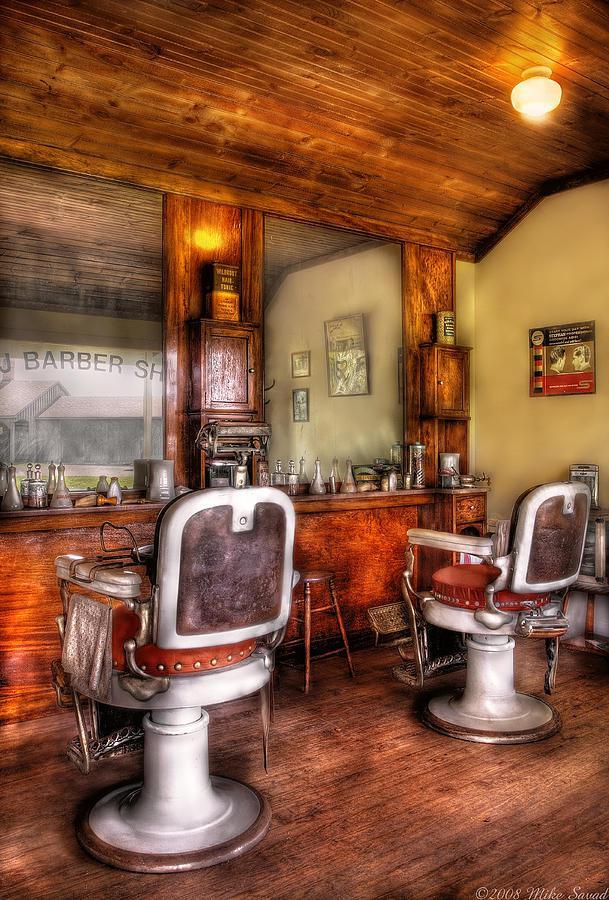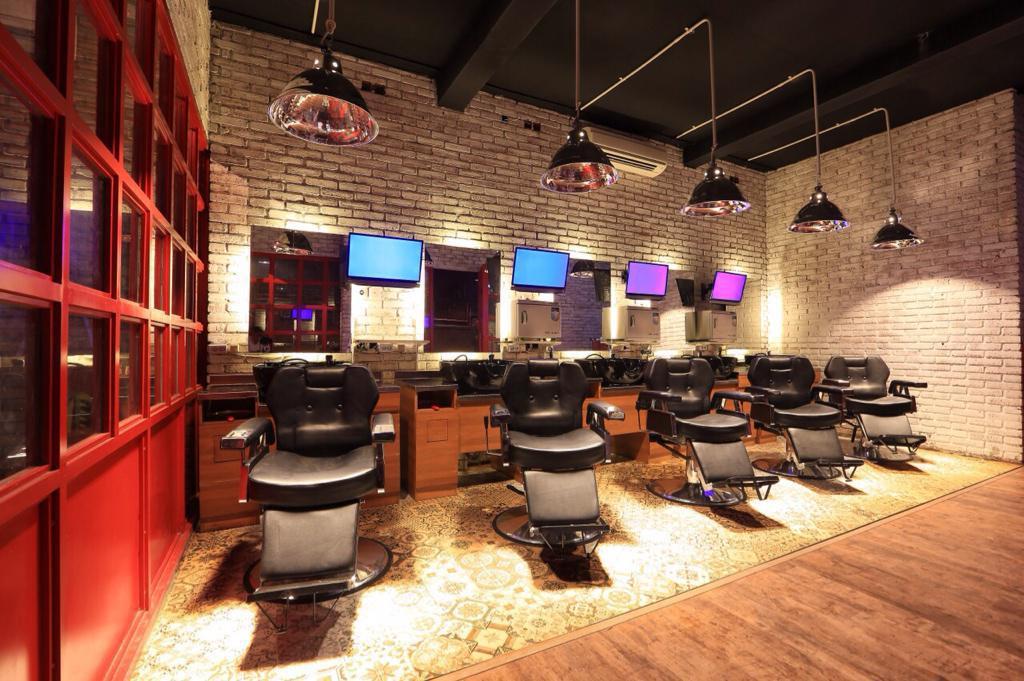The first image is the image on the left, the second image is the image on the right. Considering the images on both sides, is "At least one image shows the front side of a barber chair." valid? Answer yes or no. Yes. The first image is the image on the left, the second image is the image on the right. Given the left and right images, does the statement "A row of five black barber chairs faces the camera in one image." hold true? Answer yes or no. Yes. 